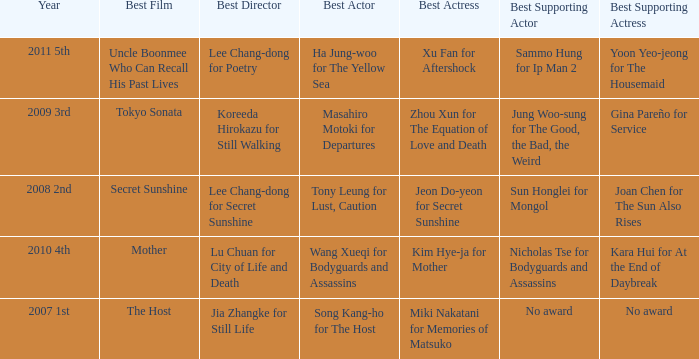Name the year for sammo hung for ip man 2 2011 5th. 